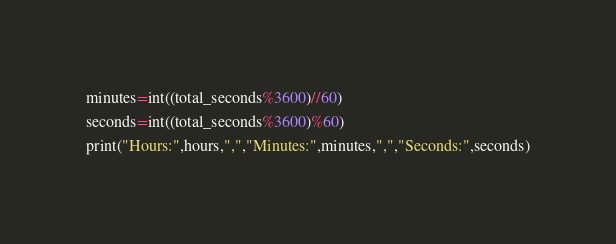Convert code to text. <code><loc_0><loc_0><loc_500><loc_500><_Python_>minutes=int((total_seconds%3600)//60)
seconds=int((total_seconds%3600)%60)
print("Hours:",hours,",","Minutes:",minutes,",","Seconds:",seconds)
</code> 